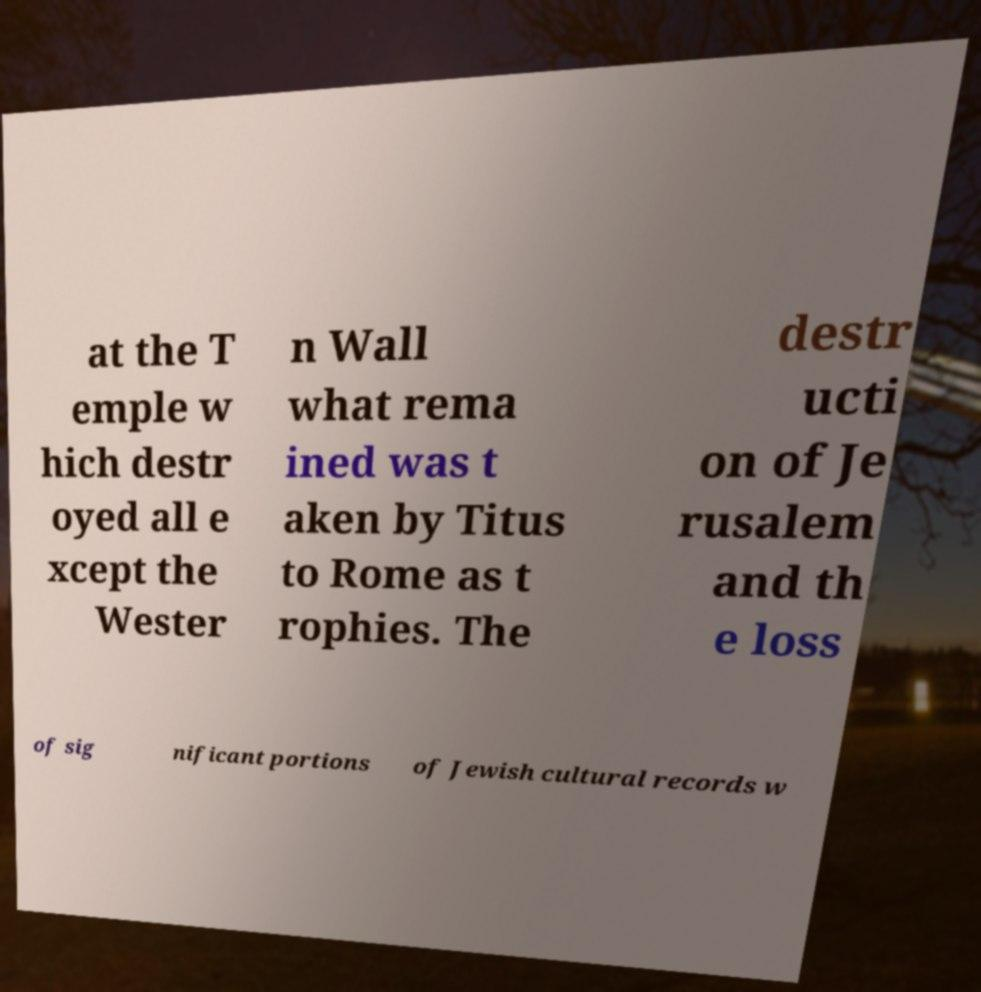Please read and relay the text visible in this image. What does it say? at the T emple w hich destr oyed all e xcept the Wester n Wall what rema ined was t aken by Titus to Rome as t rophies. The destr ucti on of Je rusalem and th e loss of sig nificant portions of Jewish cultural records w 